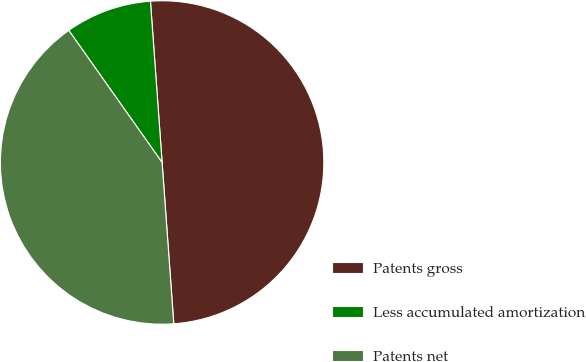Convert chart to OTSL. <chart><loc_0><loc_0><loc_500><loc_500><pie_chart><fcel>Patents gross<fcel>Less accumulated amortization<fcel>Patents net<nl><fcel>50.0%<fcel>8.64%<fcel>41.36%<nl></chart> 